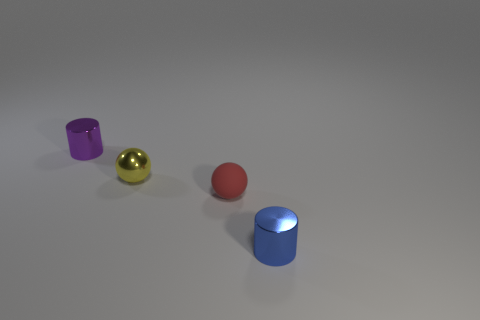Subtract 1 cylinders. How many cylinders are left? 1 Add 2 big shiny cubes. How many big shiny cubes exist? 2 Add 1 small cyan matte cylinders. How many objects exist? 5 Subtract 0 cyan cylinders. How many objects are left? 4 Subtract all yellow balls. Subtract all green blocks. How many balls are left? 1 Subtract all cyan cylinders. How many cyan balls are left? 0 Subtract all metal balls. Subtract all shiny cylinders. How many objects are left? 1 Add 4 small yellow metal things. How many small yellow metal things are left? 5 